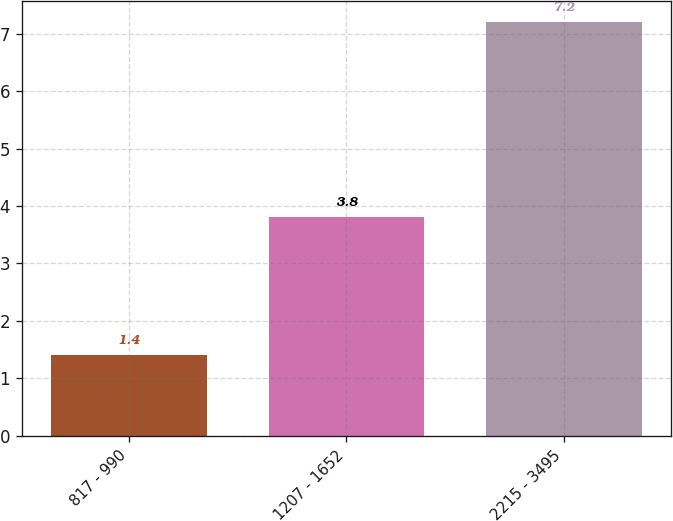<chart> <loc_0><loc_0><loc_500><loc_500><bar_chart><fcel>817 - 990<fcel>1207 - 1652<fcel>2215 - 3495<nl><fcel>1.4<fcel>3.8<fcel>7.2<nl></chart> 